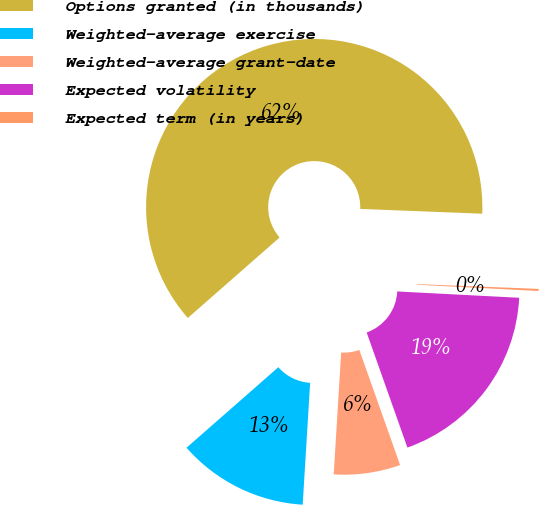<chart> <loc_0><loc_0><loc_500><loc_500><pie_chart><fcel>Options granted (in thousands)<fcel>Weighted-average exercise<fcel>Weighted-average grant-date<fcel>Expected volatility<fcel>Expected term (in years)<nl><fcel>62.08%<fcel>12.57%<fcel>6.39%<fcel>18.76%<fcel>0.2%<nl></chart> 